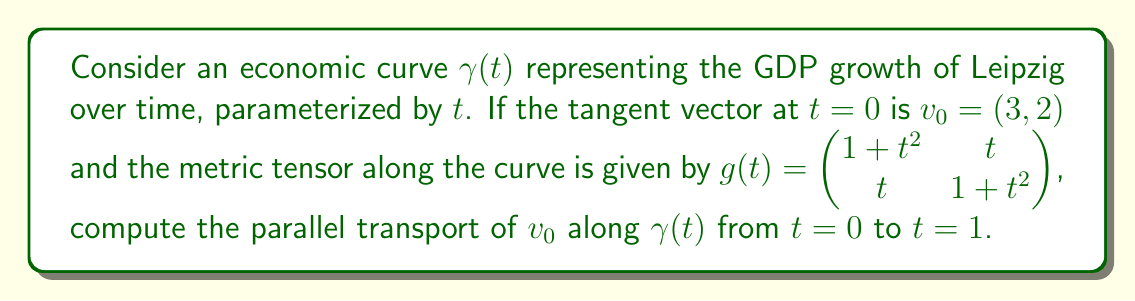Solve this math problem. To compute the parallel transport, we need to solve the parallel transport equation:

1) The parallel transport equation is given by:
   $$\frac{D v}{dt} = 0$$

2) In coordinates, this becomes:
   $$\frac{dv^i}{dt} + \Gamma^i_{jk} v^j \frac{d\gamma^k}{dt} = 0$$

3) We need to calculate the Christoffel symbols $\Gamma^i_{jk}$. For a metric $g_{ij}$, they are given by:
   $$\Gamma^i_{jk} = \frac{1}{2}g^{im}(\partial_j g_{mk} + \partial_k g_{mj} - \partial_m g_{jk})$$

4) Calculating the inverse metric:
   $$g^{-1}(t) = \frac{1}{(1+t^2)^2 - t^2} \begin{pmatrix} 1+t^2 & -t \\ -t & 1+t^2 \end{pmatrix}$$

5) Computing the Christoffel symbols (only non-zero components):
   $$\Gamma^1_{11} = \frac{2t}{1+t^2}, \Gamma^1_{12} = \Gamma^1_{21} = \frac{1}{1+t^2}, \Gamma^2_{11} = -\frac{t}{1+t^2}, \Gamma^2_{12} = \Gamma^2_{21} = \frac{t}{1+t^2}$$

6) The parallel transport equation becomes:
   $$\frac{dv^1}{dt} + \frac{2t}{1+t^2}v^1 + \frac{2}{1+t^2}v^2 = 0$$
   $$\frac{dv^2}{dt} - \frac{t}{1+t^2}v^1 + \frac{2t}{1+t^2}v^2 = 0$$

7) Solving this system of differential equations with initial condition $v_0 = (3, 2)$:
   $$v^1(t) = \frac{3+2t}{\sqrt{1+t^2}}$$
   $$v^2(t) = \frac{2+3t}{\sqrt{1+t^2}}$$

8) At $t=1$, the parallel transported vector is:
   $$v(1) = \left(\frac{5}{\sqrt{2}}, \frac{5}{\sqrt{2}}\right)$$
Answer: $\left(\frac{5}{\sqrt{2}}, \frac{5}{\sqrt{2}}\right)$ 